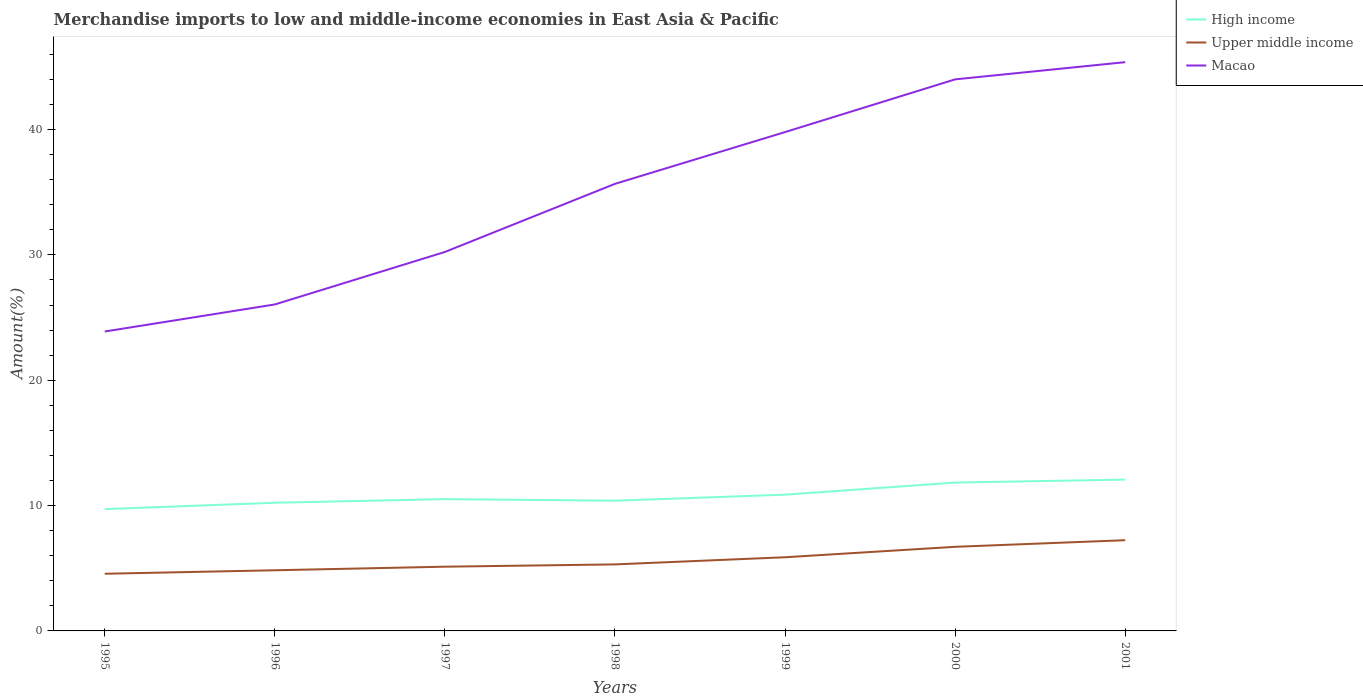How many different coloured lines are there?
Your answer should be very brief. 3. Across all years, what is the maximum percentage of amount earned from merchandise imports in Macao?
Your response must be concise. 23.89. What is the total percentage of amount earned from merchandise imports in High income in the graph?
Provide a short and direct response. -0.36. What is the difference between the highest and the second highest percentage of amount earned from merchandise imports in High income?
Provide a short and direct response. 2.35. Is the percentage of amount earned from merchandise imports in Macao strictly greater than the percentage of amount earned from merchandise imports in High income over the years?
Your answer should be very brief. No. What is the difference between two consecutive major ticks on the Y-axis?
Your answer should be very brief. 10. Does the graph contain grids?
Ensure brevity in your answer.  No. How many legend labels are there?
Your answer should be compact. 3. What is the title of the graph?
Your answer should be compact. Merchandise imports to low and middle-income economies in East Asia & Pacific. Does "United States" appear as one of the legend labels in the graph?
Your answer should be compact. No. What is the label or title of the Y-axis?
Provide a short and direct response. Amount(%). What is the Amount(%) in High income in 1995?
Your answer should be compact. 9.72. What is the Amount(%) of Upper middle income in 1995?
Give a very brief answer. 4.56. What is the Amount(%) in Macao in 1995?
Your response must be concise. 23.89. What is the Amount(%) of High income in 1996?
Make the answer very short. 10.23. What is the Amount(%) of Upper middle income in 1996?
Provide a succinct answer. 4.84. What is the Amount(%) in Macao in 1996?
Your answer should be compact. 26.05. What is the Amount(%) of High income in 1997?
Provide a short and direct response. 10.51. What is the Amount(%) of Upper middle income in 1997?
Give a very brief answer. 5.12. What is the Amount(%) of Macao in 1997?
Give a very brief answer. 30.24. What is the Amount(%) of High income in 1998?
Your answer should be very brief. 10.39. What is the Amount(%) of Upper middle income in 1998?
Offer a terse response. 5.31. What is the Amount(%) in Macao in 1998?
Your answer should be compact. 35.67. What is the Amount(%) of High income in 1999?
Make the answer very short. 10.87. What is the Amount(%) in Upper middle income in 1999?
Provide a short and direct response. 5.88. What is the Amount(%) of Macao in 1999?
Give a very brief answer. 39.8. What is the Amount(%) in High income in 2000?
Make the answer very short. 11.84. What is the Amount(%) in Upper middle income in 2000?
Keep it short and to the point. 6.71. What is the Amount(%) of Macao in 2000?
Provide a succinct answer. 44.01. What is the Amount(%) in High income in 2001?
Make the answer very short. 12.07. What is the Amount(%) of Upper middle income in 2001?
Provide a succinct answer. 7.24. What is the Amount(%) of Macao in 2001?
Ensure brevity in your answer.  45.38. Across all years, what is the maximum Amount(%) in High income?
Your answer should be very brief. 12.07. Across all years, what is the maximum Amount(%) of Upper middle income?
Provide a short and direct response. 7.24. Across all years, what is the maximum Amount(%) of Macao?
Your answer should be compact. 45.38. Across all years, what is the minimum Amount(%) of High income?
Provide a short and direct response. 9.72. Across all years, what is the minimum Amount(%) in Upper middle income?
Offer a terse response. 4.56. Across all years, what is the minimum Amount(%) in Macao?
Ensure brevity in your answer.  23.89. What is the total Amount(%) in High income in the graph?
Give a very brief answer. 75.63. What is the total Amount(%) of Upper middle income in the graph?
Provide a short and direct response. 39.66. What is the total Amount(%) of Macao in the graph?
Your answer should be compact. 245.03. What is the difference between the Amount(%) of High income in 1995 and that in 1996?
Offer a terse response. -0.51. What is the difference between the Amount(%) of Upper middle income in 1995 and that in 1996?
Offer a terse response. -0.28. What is the difference between the Amount(%) in Macao in 1995 and that in 1996?
Your response must be concise. -2.16. What is the difference between the Amount(%) of High income in 1995 and that in 1997?
Offer a terse response. -0.8. What is the difference between the Amount(%) in Upper middle income in 1995 and that in 1997?
Keep it short and to the point. -0.56. What is the difference between the Amount(%) in Macao in 1995 and that in 1997?
Ensure brevity in your answer.  -6.35. What is the difference between the Amount(%) in High income in 1995 and that in 1998?
Make the answer very short. -0.67. What is the difference between the Amount(%) in Upper middle income in 1995 and that in 1998?
Provide a succinct answer. -0.75. What is the difference between the Amount(%) of Macao in 1995 and that in 1998?
Provide a short and direct response. -11.78. What is the difference between the Amount(%) in High income in 1995 and that in 1999?
Your answer should be very brief. -1.15. What is the difference between the Amount(%) in Upper middle income in 1995 and that in 1999?
Your response must be concise. -1.32. What is the difference between the Amount(%) in Macao in 1995 and that in 1999?
Offer a very short reply. -15.91. What is the difference between the Amount(%) of High income in 1995 and that in 2000?
Your answer should be very brief. -2.12. What is the difference between the Amount(%) of Upper middle income in 1995 and that in 2000?
Ensure brevity in your answer.  -2.15. What is the difference between the Amount(%) of Macao in 1995 and that in 2000?
Offer a very short reply. -20.12. What is the difference between the Amount(%) in High income in 1995 and that in 2001?
Keep it short and to the point. -2.35. What is the difference between the Amount(%) of Upper middle income in 1995 and that in 2001?
Provide a short and direct response. -2.68. What is the difference between the Amount(%) of Macao in 1995 and that in 2001?
Your answer should be very brief. -21.49. What is the difference between the Amount(%) of High income in 1996 and that in 1997?
Offer a terse response. -0.29. What is the difference between the Amount(%) in Upper middle income in 1996 and that in 1997?
Provide a succinct answer. -0.28. What is the difference between the Amount(%) in Macao in 1996 and that in 1997?
Your answer should be very brief. -4.19. What is the difference between the Amount(%) of High income in 1996 and that in 1998?
Your response must be concise. -0.16. What is the difference between the Amount(%) of Upper middle income in 1996 and that in 1998?
Keep it short and to the point. -0.47. What is the difference between the Amount(%) in Macao in 1996 and that in 1998?
Give a very brief answer. -9.62. What is the difference between the Amount(%) of High income in 1996 and that in 1999?
Offer a very short reply. -0.64. What is the difference between the Amount(%) in Upper middle income in 1996 and that in 1999?
Your response must be concise. -1.04. What is the difference between the Amount(%) of Macao in 1996 and that in 1999?
Make the answer very short. -13.75. What is the difference between the Amount(%) in High income in 1996 and that in 2000?
Offer a very short reply. -1.61. What is the difference between the Amount(%) in Upper middle income in 1996 and that in 2000?
Keep it short and to the point. -1.87. What is the difference between the Amount(%) of Macao in 1996 and that in 2000?
Your answer should be compact. -17.96. What is the difference between the Amount(%) of High income in 1996 and that in 2001?
Offer a very short reply. -1.85. What is the difference between the Amount(%) of Upper middle income in 1996 and that in 2001?
Your answer should be very brief. -2.4. What is the difference between the Amount(%) in Macao in 1996 and that in 2001?
Ensure brevity in your answer.  -19.33. What is the difference between the Amount(%) of High income in 1997 and that in 1998?
Keep it short and to the point. 0.12. What is the difference between the Amount(%) in Upper middle income in 1997 and that in 1998?
Offer a very short reply. -0.18. What is the difference between the Amount(%) of Macao in 1997 and that in 1998?
Your answer should be compact. -5.43. What is the difference between the Amount(%) of High income in 1997 and that in 1999?
Provide a short and direct response. -0.36. What is the difference between the Amount(%) of Upper middle income in 1997 and that in 1999?
Offer a very short reply. -0.75. What is the difference between the Amount(%) in Macao in 1997 and that in 1999?
Keep it short and to the point. -9.56. What is the difference between the Amount(%) of High income in 1997 and that in 2000?
Ensure brevity in your answer.  -1.32. What is the difference between the Amount(%) in Upper middle income in 1997 and that in 2000?
Give a very brief answer. -1.59. What is the difference between the Amount(%) in Macao in 1997 and that in 2000?
Your response must be concise. -13.77. What is the difference between the Amount(%) in High income in 1997 and that in 2001?
Offer a terse response. -1.56. What is the difference between the Amount(%) of Upper middle income in 1997 and that in 2001?
Provide a succinct answer. -2.11. What is the difference between the Amount(%) of Macao in 1997 and that in 2001?
Give a very brief answer. -15.14. What is the difference between the Amount(%) of High income in 1998 and that in 1999?
Make the answer very short. -0.48. What is the difference between the Amount(%) in Upper middle income in 1998 and that in 1999?
Give a very brief answer. -0.57. What is the difference between the Amount(%) of Macao in 1998 and that in 1999?
Make the answer very short. -4.13. What is the difference between the Amount(%) in High income in 1998 and that in 2000?
Give a very brief answer. -1.45. What is the difference between the Amount(%) of Upper middle income in 1998 and that in 2000?
Keep it short and to the point. -1.4. What is the difference between the Amount(%) of Macao in 1998 and that in 2000?
Your response must be concise. -8.34. What is the difference between the Amount(%) of High income in 1998 and that in 2001?
Your answer should be very brief. -1.68. What is the difference between the Amount(%) in Upper middle income in 1998 and that in 2001?
Make the answer very short. -1.93. What is the difference between the Amount(%) in Macao in 1998 and that in 2001?
Your response must be concise. -9.71. What is the difference between the Amount(%) of High income in 1999 and that in 2000?
Ensure brevity in your answer.  -0.97. What is the difference between the Amount(%) of Upper middle income in 1999 and that in 2000?
Your answer should be compact. -0.83. What is the difference between the Amount(%) of Macao in 1999 and that in 2000?
Provide a succinct answer. -4.21. What is the difference between the Amount(%) in High income in 1999 and that in 2001?
Provide a short and direct response. -1.2. What is the difference between the Amount(%) in Upper middle income in 1999 and that in 2001?
Offer a very short reply. -1.36. What is the difference between the Amount(%) in Macao in 1999 and that in 2001?
Ensure brevity in your answer.  -5.58. What is the difference between the Amount(%) of High income in 2000 and that in 2001?
Give a very brief answer. -0.24. What is the difference between the Amount(%) of Upper middle income in 2000 and that in 2001?
Keep it short and to the point. -0.53. What is the difference between the Amount(%) of Macao in 2000 and that in 2001?
Provide a succinct answer. -1.37. What is the difference between the Amount(%) in High income in 1995 and the Amount(%) in Upper middle income in 1996?
Make the answer very short. 4.88. What is the difference between the Amount(%) of High income in 1995 and the Amount(%) of Macao in 1996?
Offer a terse response. -16.33. What is the difference between the Amount(%) of Upper middle income in 1995 and the Amount(%) of Macao in 1996?
Ensure brevity in your answer.  -21.49. What is the difference between the Amount(%) in High income in 1995 and the Amount(%) in Upper middle income in 1997?
Offer a terse response. 4.59. What is the difference between the Amount(%) in High income in 1995 and the Amount(%) in Macao in 1997?
Offer a terse response. -20.52. What is the difference between the Amount(%) of Upper middle income in 1995 and the Amount(%) of Macao in 1997?
Your answer should be compact. -25.68. What is the difference between the Amount(%) in High income in 1995 and the Amount(%) in Upper middle income in 1998?
Your answer should be very brief. 4.41. What is the difference between the Amount(%) of High income in 1995 and the Amount(%) of Macao in 1998?
Provide a succinct answer. -25.95. What is the difference between the Amount(%) of Upper middle income in 1995 and the Amount(%) of Macao in 1998?
Give a very brief answer. -31.11. What is the difference between the Amount(%) in High income in 1995 and the Amount(%) in Upper middle income in 1999?
Your response must be concise. 3.84. What is the difference between the Amount(%) in High income in 1995 and the Amount(%) in Macao in 1999?
Offer a terse response. -30.08. What is the difference between the Amount(%) of Upper middle income in 1995 and the Amount(%) of Macao in 1999?
Your answer should be compact. -35.24. What is the difference between the Amount(%) of High income in 1995 and the Amount(%) of Upper middle income in 2000?
Your response must be concise. 3.01. What is the difference between the Amount(%) of High income in 1995 and the Amount(%) of Macao in 2000?
Keep it short and to the point. -34.29. What is the difference between the Amount(%) of Upper middle income in 1995 and the Amount(%) of Macao in 2000?
Your response must be concise. -39.45. What is the difference between the Amount(%) of High income in 1995 and the Amount(%) of Upper middle income in 2001?
Your answer should be very brief. 2.48. What is the difference between the Amount(%) of High income in 1995 and the Amount(%) of Macao in 2001?
Give a very brief answer. -35.66. What is the difference between the Amount(%) of Upper middle income in 1995 and the Amount(%) of Macao in 2001?
Provide a short and direct response. -40.82. What is the difference between the Amount(%) of High income in 1996 and the Amount(%) of Upper middle income in 1997?
Keep it short and to the point. 5.1. What is the difference between the Amount(%) of High income in 1996 and the Amount(%) of Macao in 1997?
Your answer should be compact. -20.01. What is the difference between the Amount(%) in Upper middle income in 1996 and the Amount(%) in Macao in 1997?
Give a very brief answer. -25.4. What is the difference between the Amount(%) in High income in 1996 and the Amount(%) in Upper middle income in 1998?
Keep it short and to the point. 4.92. What is the difference between the Amount(%) of High income in 1996 and the Amount(%) of Macao in 1998?
Your answer should be very brief. -25.44. What is the difference between the Amount(%) in Upper middle income in 1996 and the Amount(%) in Macao in 1998?
Your response must be concise. -30.83. What is the difference between the Amount(%) of High income in 1996 and the Amount(%) of Upper middle income in 1999?
Provide a short and direct response. 4.35. What is the difference between the Amount(%) in High income in 1996 and the Amount(%) in Macao in 1999?
Offer a very short reply. -29.57. What is the difference between the Amount(%) in Upper middle income in 1996 and the Amount(%) in Macao in 1999?
Make the answer very short. -34.96. What is the difference between the Amount(%) in High income in 1996 and the Amount(%) in Upper middle income in 2000?
Your response must be concise. 3.52. What is the difference between the Amount(%) of High income in 1996 and the Amount(%) of Macao in 2000?
Keep it short and to the point. -33.78. What is the difference between the Amount(%) in Upper middle income in 1996 and the Amount(%) in Macao in 2000?
Your response must be concise. -39.17. What is the difference between the Amount(%) of High income in 1996 and the Amount(%) of Upper middle income in 2001?
Keep it short and to the point. 2.99. What is the difference between the Amount(%) of High income in 1996 and the Amount(%) of Macao in 2001?
Give a very brief answer. -35.15. What is the difference between the Amount(%) in Upper middle income in 1996 and the Amount(%) in Macao in 2001?
Provide a succinct answer. -40.54. What is the difference between the Amount(%) of High income in 1997 and the Amount(%) of Upper middle income in 1998?
Give a very brief answer. 5.21. What is the difference between the Amount(%) of High income in 1997 and the Amount(%) of Macao in 1998?
Make the answer very short. -25.16. What is the difference between the Amount(%) of Upper middle income in 1997 and the Amount(%) of Macao in 1998?
Offer a terse response. -30.55. What is the difference between the Amount(%) of High income in 1997 and the Amount(%) of Upper middle income in 1999?
Provide a succinct answer. 4.64. What is the difference between the Amount(%) in High income in 1997 and the Amount(%) in Macao in 1999?
Your answer should be compact. -29.29. What is the difference between the Amount(%) in Upper middle income in 1997 and the Amount(%) in Macao in 1999?
Give a very brief answer. -34.68. What is the difference between the Amount(%) of High income in 1997 and the Amount(%) of Upper middle income in 2000?
Make the answer very short. 3.8. What is the difference between the Amount(%) in High income in 1997 and the Amount(%) in Macao in 2000?
Give a very brief answer. -33.49. What is the difference between the Amount(%) of Upper middle income in 1997 and the Amount(%) of Macao in 2000?
Offer a very short reply. -38.88. What is the difference between the Amount(%) of High income in 1997 and the Amount(%) of Upper middle income in 2001?
Provide a succinct answer. 3.28. What is the difference between the Amount(%) of High income in 1997 and the Amount(%) of Macao in 2001?
Keep it short and to the point. -34.87. What is the difference between the Amount(%) in Upper middle income in 1997 and the Amount(%) in Macao in 2001?
Your answer should be very brief. -40.26. What is the difference between the Amount(%) of High income in 1998 and the Amount(%) of Upper middle income in 1999?
Ensure brevity in your answer.  4.51. What is the difference between the Amount(%) of High income in 1998 and the Amount(%) of Macao in 1999?
Provide a short and direct response. -29.41. What is the difference between the Amount(%) in Upper middle income in 1998 and the Amount(%) in Macao in 1999?
Your answer should be very brief. -34.49. What is the difference between the Amount(%) in High income in 1998 and the Amount(%) in Upper middle income in 2000?
Provide a short and direct response. 3.68. What is the difference between the Amount(%) of High income in 1998 and the Amount(%) of Macao in 2000?
Your answer should be very brief. -33.62. What is the difference between the Amount(%) of Upper middle income in 1998 and the Amount(%) of Macao in 2000?
Offer a very short reply. -38.7. What is the difference between the Amount(%) in High income in 1998 and the Amount(%) in Upper middle income in 2001?
Your answer should be very brief. 3.15. What is the difference between the Amount(%) of High income in 1998 and the Amount(%) of Macao in 2001?
Your response must be concise. -34.99. What is the difference between the Amount(%) in Upper middle income in 1998 and the Amount(%) in Macao in 2001?
Make the answer very short. -40.07. What is the difference between the Amount(%) of High income in 1999 and the Amount(%) of Upper middle income in 2000?
Offer a very short reply. 4.16. What is the difference between the Amount(%) in High income in 1999 and the Amount(%) in Macao in 2000?
Your answer should be compact. -33.13. What is the difference between the Amount(%) of Upper middle income in 1999 and the Amount(%) of Macao in 2000?
Your answer should be compact. -38.13. What is the difference between the Amount(%) in High income in 1999 and the Amount(%) in Upper middle income in 2001?
Provide a short and direct response. 3.63. What is the difference between the Amount(%) of High income in 1999 and the Amount(%) of Macao in 2001?
Your response must be concise. -34.51. What is the difference between the Amount(%) of Upper middle income in 1999 and the Amount(%) of Macao in 2001?
Provide a succinct answer. -39.5. What is the difference between the Amount(%) in High income in 2000 and the Amount(%) in Upper middle income in 2001?
Your answer should be compact. 4.6. What is the difference between the Amount(%) in High income in 2000 and the Amount(%) in Macao in 2001?
Your response must be concise. -33.54. What is the difference between the Amount(%) in Upper middle income in 2000 and the Amount(%) in Macao in 2001?
Ensure brevity in your answer.  -38.67. What is the average Amount(%) of High income per year?
Make the answer very short. 10.8. What is the average Amount(%) in Upper middle income per year?
Give a very brief answer. 5.67. What is the average Amount(%) of Macao per year?
Ensure brevity in your answer.  35. In the year 1995, what is the difference between the Amount(%) in High income and Amount(%) in Upper middle income?
Your answer should be compact. 5.16. In the year 1995, what is the difference between the Amount(%) in High income and Amount(%) in Macao?
Give a very brief answer. -14.17. In the year 1995, what is the difference between the Amount(%) in Upper middle income and Amount(%) in Macao?
Give a very brief answer. -19.33. In the year 1996, what is the difference between the Amount(%) in High income and Amount(%) in Upper middle income?
Your answer should be very brief. 5.39. In the year 1996, what is the difference between the Amount(%) of High income and Amount(%) of Macao?
Provide a short and direct response. -15.82. In the year 1996, what is the difference between the Amount(%) in Upper middle income and Amount(%) in Macao?
Ensure brevity in your answer.  -21.21. In the year 1997, what is the difference between the Amount(%) in High income and Amount(%) in Upper middle income?
Your answer should be compact. 5.39. In the year 1997, what is the difference between the Amount(%) in High income and Amount(%) in Macao?
Offer a very short reply. -19.72. In the year 1997, what is the difference between the Amount(%) of Upper middle income and Amount(%) of Macao?
Give a very brief answer. -25.11. In the year 1998, what is the difference between the Amount(%) in High income and Amount(%) in Upper middle income?
Your answer should be very brief. 5.08. In the year 1998, what is the difference between the Amount(%) in High income and Amount(%) in Macao?
Make the answer very short. -25.28. In the year 1998, what is the difference between the Amount(%) in Upper middle income and Amount(%) in Macao?
Ensure brevity in your answer.  -30.36. In the year 1999, what is the difference between the Amount(%) of High income and Amount(%) of Upper middle income?
Keep it short and to the point. 4.99. In the year 1999, what is the difference between the Amount(%) of High income and Amount(%) of Macao?
Offer a terse response. -28.93. In the year 1999, what is the difference between the Amount(%) in Upper middle income and Amount(%) in Macao?
Give a very brief answer. -33.92. In the year 2000, what is the difference between the Amount(%) in High income and Amount(%) in Upper middle income?
Offer a terse response. 5.13. In the year 2000, what is the difference between the Amount(%) of High income and Amount(%) of Macao?
Your answer should be very brief. -32.17. In the year 2000, what is the difference between the Amount(%) of Upper middle income and Amount(%) of Macao?
Make the answer very short. -37.3. In the year 2001, what is the difference between the Amount(%) in High income and Amount(%) in Upper middle income?
Make the answer very short. 4.83. In the year 2001, what is the difference between the Amount(%) of High income and Amount(%) of Macao?
Offer a very short reply. -33.31. In the year 2001, what is the difference between the Amount(%) in Upper middle income and Amount(%) in Macao?
Make the answer very short. -38.14. What is the ratio of the Amount(%) in High income in 1995 to that in 1996?
Offer a terse response. 0.95. What is the ratio of the Amount(%) of Upper middle income in 1995 to that in 1996?
Give a very brief answer. 0.94. What is the ratio of the Amount(%) of Macao in 1995 to that in 1996?
Ensure brevity in your answer.  0.92. What is the ratio of the Amount(%) of High income in 1995 to that in 1997?
Your answer should be very brief. 0.92. What is the ratio of the Amount(%) of Upper middle income in 1995 to that in 1997?
Offer a very short reply. 0.89. What is the ratio of the Amount(%) in Macao in 1995 to that in 1997?
Give a very brief answer. 0.79. What is the ratio of the Amount(%) of High income in 1995 to that in 1998?
Offer a very short reply. 0.94. What is the ratio of the Amount(%) of Upper middle income in 1995 to that in 1998?
Keep it short and to the point. 0.86. What is the ratio of the Amount(%) in Macao in 1995 to that in 1998?
Your response must be concise. 0.67. What is the ratio of the Amount(%) of High income in 1995 to that in 1999?
Keep it short and to the point. 0.89. What is the ratio of the Amount(%) of Upper middle income in 1995 to that in 1999?
Your response must be concise. 0.78. What is the ratio of the Amount(%) of Macao in 1995 to that in 1999?
Offer a terse response. 0.6. What is the ratio of the Amount(%) of High income in 1995 to that in 2000?
Your response must be concise. 0.82. What is the ratio of the Amount(%) of Upper middle income in 1995 to that in 2000?
Make the answer very short. 0.68. What is the ratio of the Amount(%) of Macao in 1995 to that in 2000?
Offer a terse response. 0.54. What is the ratio of the Amount(%) in High income in 1995 to that in 2001?
Provide a short and direct response. 0.81. What is the ratio of the Amount(%) of Upper middle income in 1995 to that in 2001?
Provide a succinct answer. 0.63. What is the ratio of the Amount(%) of Macao in 1995 to that in 2001?
Ensure brevity in your answer.  0.53. What is the ratio of the Amount(%) in High income in 1996 to that in 1997?
Keep it short and to the point. 0.97. What is the ratio of the Amount(%) of Upper middle income in 1996 to that in 1997?
Offer a very short reply. 0.94. What is the ratio of the Amount(%) in Macao in 1996 to that in 1997?
Your response must be concise. 0.86. What is the ratio of the Amount(%) of High income in 1996 to that in 1998?
Your answer should be very brief. 0.98. What is the ratio of the Amount(%) of Upper middle income in 1996 to that in 1998?
Offer a very short reply. 0.91. What is the ratio of the Amount(%) of Macao in 1996 to that in 1998?
Your response must be concise. 0.73. What is the ratio of the Amount(%) in High income in 1996 to that in 1999?
Your answer should be very brief. 0.94. What is the ratio of the Amount(%) in Upper middle income in 1996 to that in 1999?
Your answer should be very brief. 0.82. What is the ratio of the Amount(%) of Macao in 1996 to that in 1999?
Ensure brevity in your answer.  0.65. What is the ratio of the Amount(%) of High income in 1996 to that in 2000?
Offer a very short reply. 0.86. What is the ratio of the Amount(%) of Upper middle income in 1996 to that in 2000?
Offer a very short reply. 0.72. What is the ratio of the Amount(%) of Macao in 1996 to that in 2000?
Make the answer very short. 0.59. What is the ratio of the Amount(%) of High income in 1996 to that in 2001?
Your answer should be very brief. 0.85. What is the ratio of the Amount(%) in Upper middle income in 1996 to that in 2001?
Your answer should be compact. 0.67. What is the ratio of the Amount(%) in Macao in 1996 to that in 2001?
Provide a short and direct response. 0.57. What is the ratio of the Amount(%) of High income in 1997 to that in 1998?
Give a very brief answer. 1.01. What is the ratio of the Amount(%) in Upper middle income in 1997 to that in 1998?
Make the answer very short. 0.97. What is the ratio of the Amount(%) in Macao in 1997 to that in 1998?
Your answer should be compact. 0.85. What is the ratio of the Amount(%) in High income in 1997 to that in 1999?
Your answer should be compact. 0.97. What is the ratio of the Amount(%) in Upper middle income in 1997 to that in 1999?
Give a very brief answer. 0.87. What is the ratio of the Amount(%) of Macao in 1997 to that in 1999?
Offer a very short reply. 0.76. What is the ratio of the Amount(%) of High income in 1997 to that in 2000?
Keep it short and to the point. 0.89. What is the ratio of the Amount(%) of Upper middle income in 1997 to that in 2000?
Keep it short and to the point. 0.76. What is the ratio of the Amount(%) in Macao in 1997 to that in 2000?
Offer a terse response. 0.69. What is the ratio of the Amount(%) of High income in 1997 to that in 2001?
Offer a very short reply. 0.87. What is the ratio of the Amount(%) in Upper middle income in 1997 to that in 2001?
Your answer should be very brief. 0.71. What is the ratio of the Amount(%) of Macao in 1997 to that in 2001?
Make the answer very short. 0.67. What is the ratio of the Amount(%) in High income in 1998 to that in 1999?
Keep it short and to the point. 0.96. What is the ratio of the Amount(%) of Upper middle income in 1998 to that in 1999?
Your answer should be very brief. 0.9. What is the ratio of the Amount(%) in Macao in 1998 to that in 1999?
Your response must be concise. 0.9. What is the ratio of the Amount(%) in High income in 1998 to that in 2000?
Ensure brevity in your answer.  0.88. What is the ratio of the Amount(%) of Upper middle income in 1998 to that in 2000?
Your answer should be compact. 0.79. What is the ratio of the Amount(%) in Macao in 1998 to that in 2000?
Provide a succinct answer. 0.81. What is the ratio of the Amount(%) in High income in 1998 to that in 2001?
Make the answer very short. 0.86. What is the ratio of the Amount(%) in Upper middle income in 1998 to that in 2001?
Offer a very short reply. 0.73. What is the ratio of the Amount(%) in Macao in 1998 to that in 2001?
Your response must be concise. 0.79. What is the ratio of the Amount(%) of High income in 1999 to that in 2000?
Your answer should be compact. 0.92. What is the ratio of the Amount(%) in Upper middle income in 1999 to that in 2000?
Ensure brevity in your answer.  0.88. What is the ratio of the Amount(%) in Macao in 1999 to that in 2000?
Your response must be concise. 0.9. What is the ratio of the Amount(%) of High income in 1999 to that in 2001?
Offer a terse response. 0.9. What is the ratio of the Amount(%) in Upper middle income in 1999 to that in 2001?
Provide a short and direct response. 0.81. What is the ratio of the Amount(%) in Macao in 1999 to that in 2001?
Make the answer very short. 0.88. What is the ratio of the Amount(%) of High income in 2000 to that in 2001?
Give a very brief answer. 0.98. What is the ratio of the Amount(%) in Upper middle income in 2000 to that in 2001?
Ensure brevity in your answer.  0.93. What is the ratio of the Amount(%) in Macao in 2000 to that in 2001?
Offer a very short reply. 0.97. What is the difference between the highest and the second highest Amount(%) of High income?
Offer a very short reply. 0.24. What is the difference between the highest and the second highest Amount(%) of Upper middle income?
Give a very brief answer. 0.53. What is the difference between the highest and the second highest Amount(%) of Macao?
Give a very brief answer. 1.37. What is the difference between the highest and the lowest Amount(%) in High income?
Ensure brevity in your answer.  2.35. What is the difference between the highest and the lowest Amount(%) of Upper middle income?
Your response must be concise. 2.68. What is the difference between the highest and the lowest Amount(%) of Macao?
Give a very brief answer. 21.49. 